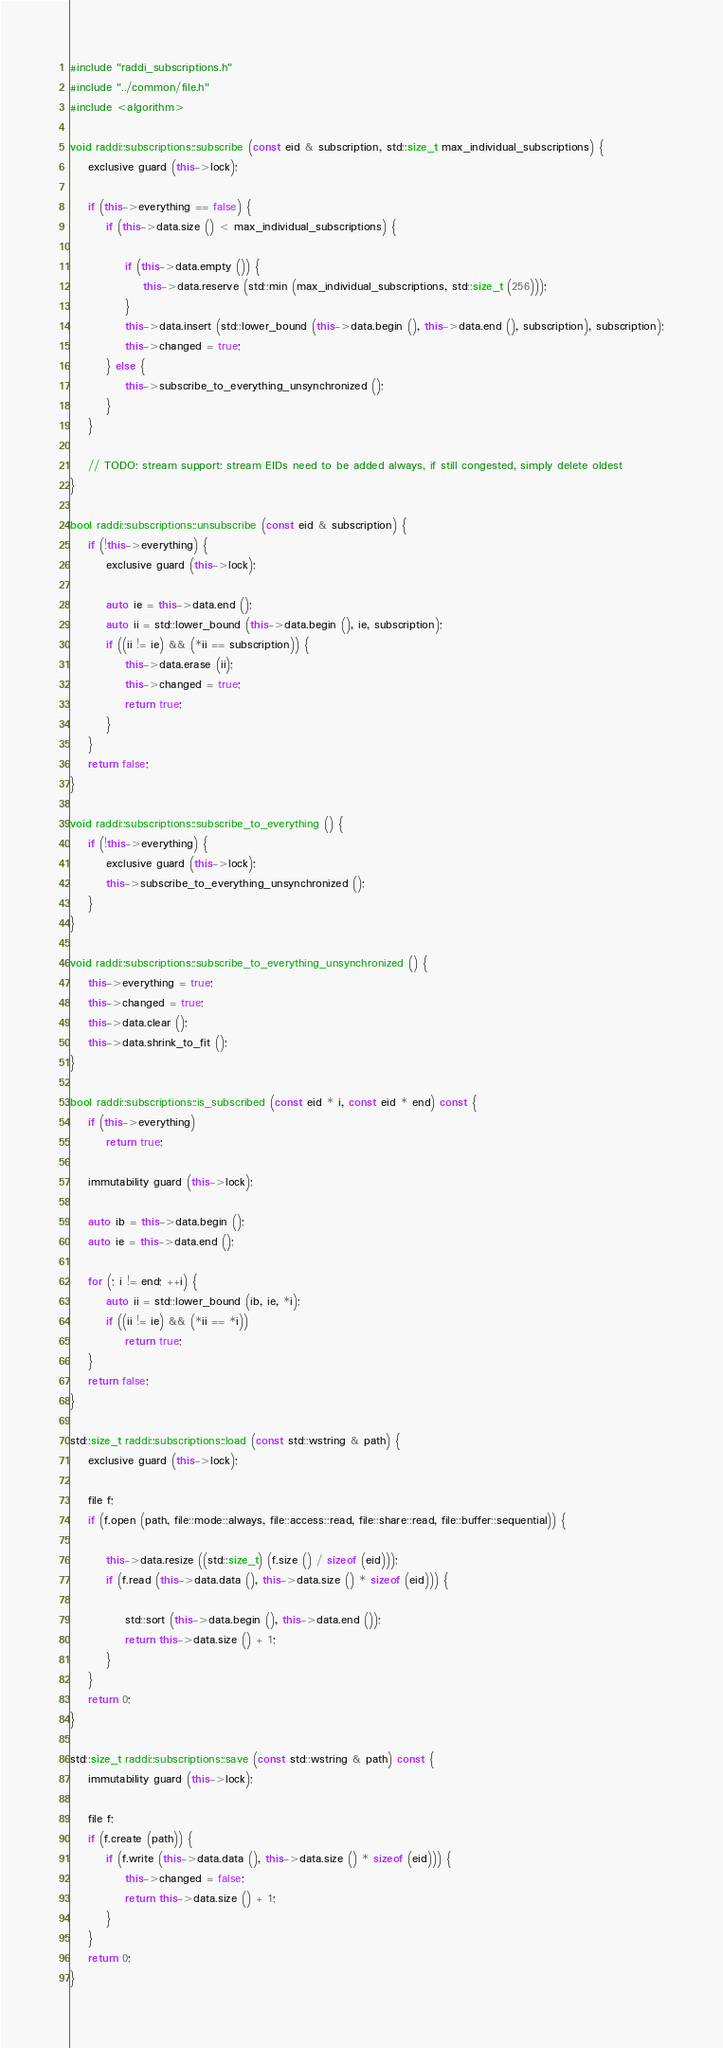<code> <loc_0><loc_0><loc_500><loc_500><_C++_>#include "raddi_subscriptions.h"
#include "../common/file.h"
#include <algorithm>

void raddi::subscriptions::subscribe (const eid & subscription, std::size_t max_individual_subscriptions) {
    exclusive guard (this->lock);

    if (this->everything == false) {
        if (this->data.size () < max_individual_subscriptions) {

            if (this->data.empty ()) {
                this->data.reserve (std::min (max_individual_subscriptions, std::size_t (256)));
            }
            this->data.insert (std::lower_bound (this->data.begin (), this->data.end (), subscription), subscription);
            this->changed = true;
        } else {
            this->subscribe_to_everything_unsynchronized ();
        }
    }

    // TODO: stream support: stream EIDs need to be added always, if still congested, simply delete oldest
}

bool raddi::subscriptions::unsubscribe (const eid & subscription) {
    if (!this->everything) {
        exclusive guard (this->lock);

        auto ie = this->data.end ();
        auto ii = std::lower_bound (this->data.begin (), ie, subscription);
        if ((ii != ie) && (*ii == subscription)) {
            this->data.erase (ii);
            this->changed = true;
            return true;
        }
    }
    return false;
}

void raddi::subscriptions::subscribe_to_everything () {
    if (!this->everything) {
        exclusive guard (this->lock);
        this->subscribe_to_everything_unsynchronized ();
    }
}

void raddi::subscriptions::subscribe_to_everything_unsynchronized () {
    this->everything = true;
    this->changed = true;
    this->data.clear ();
    this->data.shrink_to_fit ();
}

bool raddi::subscriptions::is_subscribed (const eid * i, const eid * end) const {
    if (this->everything)
        return true;

    immutability guard (this->lock);

    auto ib = this->data.begin ();
    auto ie = this->data.end ();

    for (; i != end; ++i) {
        auto ii = std::lower_bound (ib, ie, *i);
        if ((ii != ie) && (*ii == *i))
            return true;
    }
    return false;
}

std::size_t raddi::subscriptions::load (const std::wstring & path) {
    exclusive guard (this->lock);

    file f;
    if (f.open (path, file::mode::always, file::access::read, file::share::read, file::buffer::sequential)) {

        this->data.resize ((std::size_t) (f.size () / sizeof (eid)));
        if (f.read (this->data.data (), this->data.size () * sizeof (eid))) {

            std::sort (this->data.begin (), this->data.end ());
            return this->data.size () + 1;
        }
    }
    return 0;
}

std::size_t raddi::subscriptions::save (const std::wstring & path) const {
    immutability guard (this->lock);

    file f;
    if (f.create (path)) {
        if (f.write (this->data.data (), this->data.size () * sizeof (eid))) {
            this->changed = false;
            return this->data.size () + 1;
        }
    }
    return 0;
}
</code> 